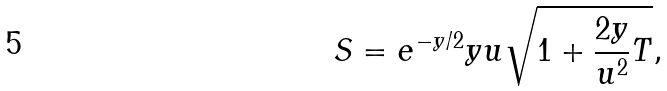<formula> <loc_0><loc_0><loc_500><loc_500>S = e ^ { - y / 2 } y u \sqrt { 1 + \frac { 2 y } { u ^ { 2 } } T } ,</formula> 